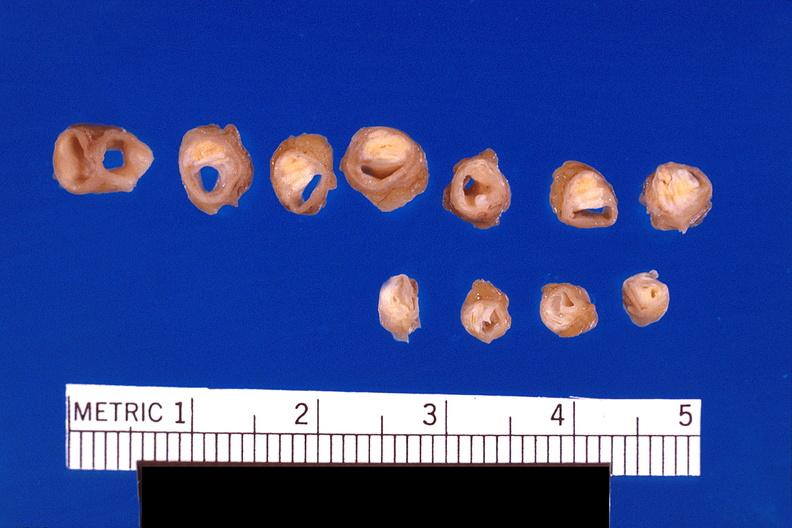s lesion present?
Answer the question using a single word or phrase. No 